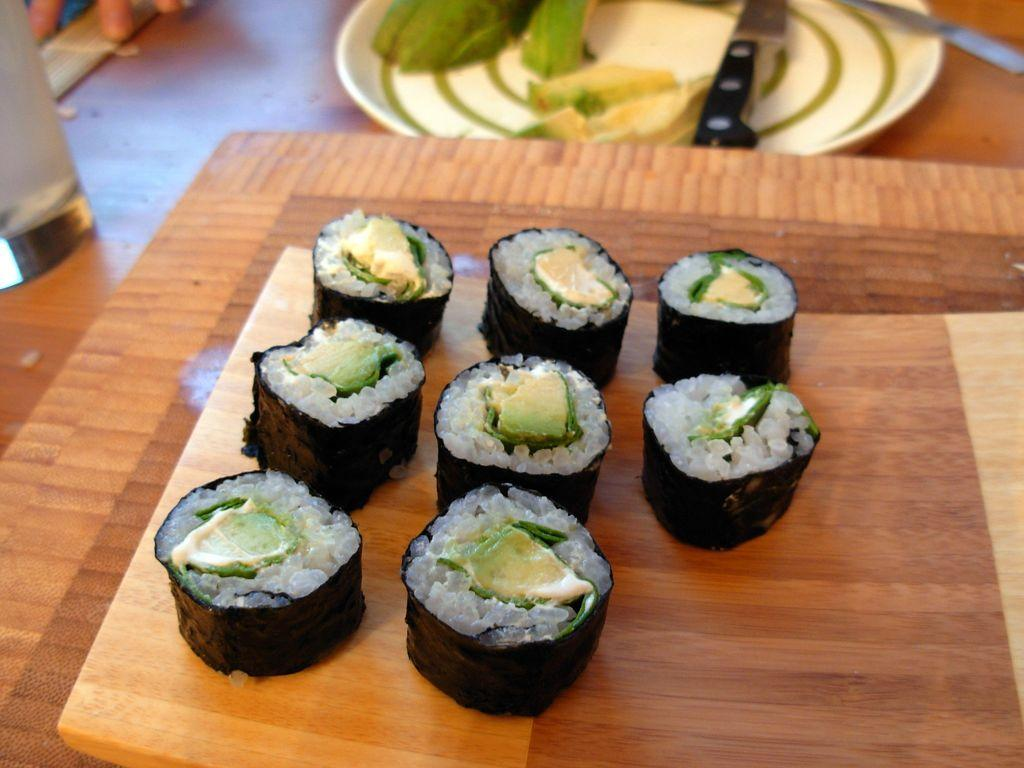What is on the table in the image? There is a platform on a table in the image. What is on the platform? Food items are present on the platform. What is on the left side of the table? There is a glass on the left side of the table. What is on the plate in the image? Food items and knives are on a plate in the image. Are there any other objects on the table? Yes, there are other objects on the table. What type of pie is being shared between partners in the image? There is no pie or partners present in the image. How does the image end? The image does not have an ending, as it is a still image and not a video or story. 